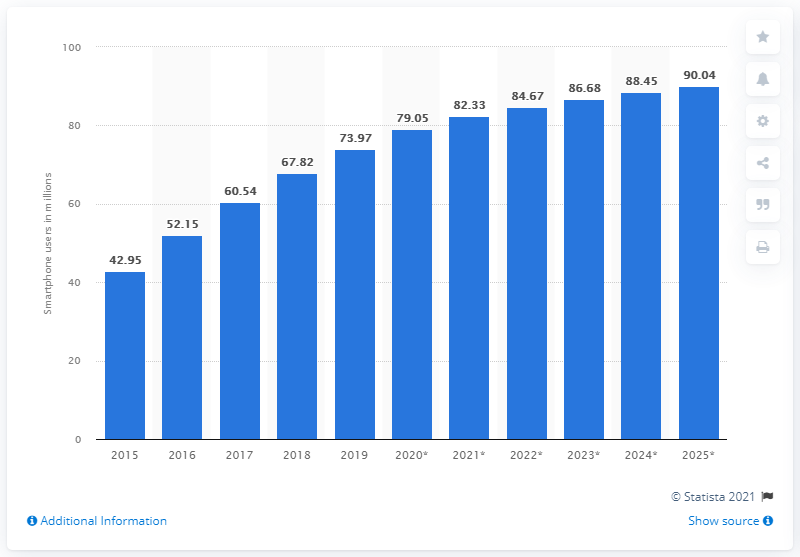Point out several critical features in this image. In 2019, there were 73.97 million smartphone users in the Philippines. By 2025, it is projected that there will be 90.04 million smartphone users in the Philippines. 